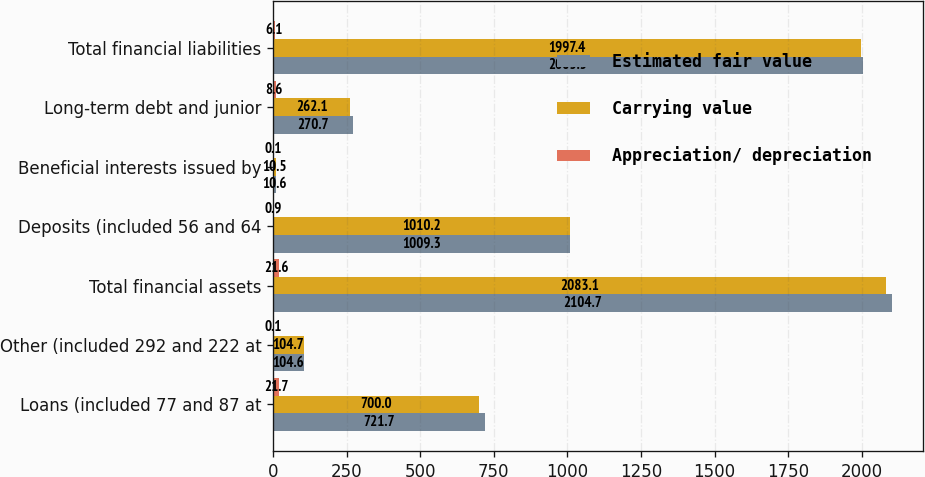<chart> <loc_0><loc_0><loc_500><loc_500><stacked_bar_chart><ecel><fcel>Loans (included 77 and 87 at<fcel>Other (included 292 and 222 at<fcel>Total financial assets<fcel>Deposits (included 56 and 64<fcel>Beneficial interests issued by<fcel>Long-term debt and junior<fcel>Total financial liabilities<nl><fcel>Estimated fair value<fcel>721.7<fcel>104.6<fcel>2104.7<fcel>1009.3<fcel>10.6<fcel>270.7<fcel>2003.5<nl><fcel>Carrying value<fcel>700<fcel>104.7<fcel>2083.1<fcel>1010.2<fcel>10.5<fcel>262.1<fcel>1997.4<nl><fcel>Appreciation/ depreciation<fcel>21.7<fcel>0.1<fcel>21.6<fcel>0.9<fcel>0.1<fcel>8.6<fcel>6.1<nl></chart> 